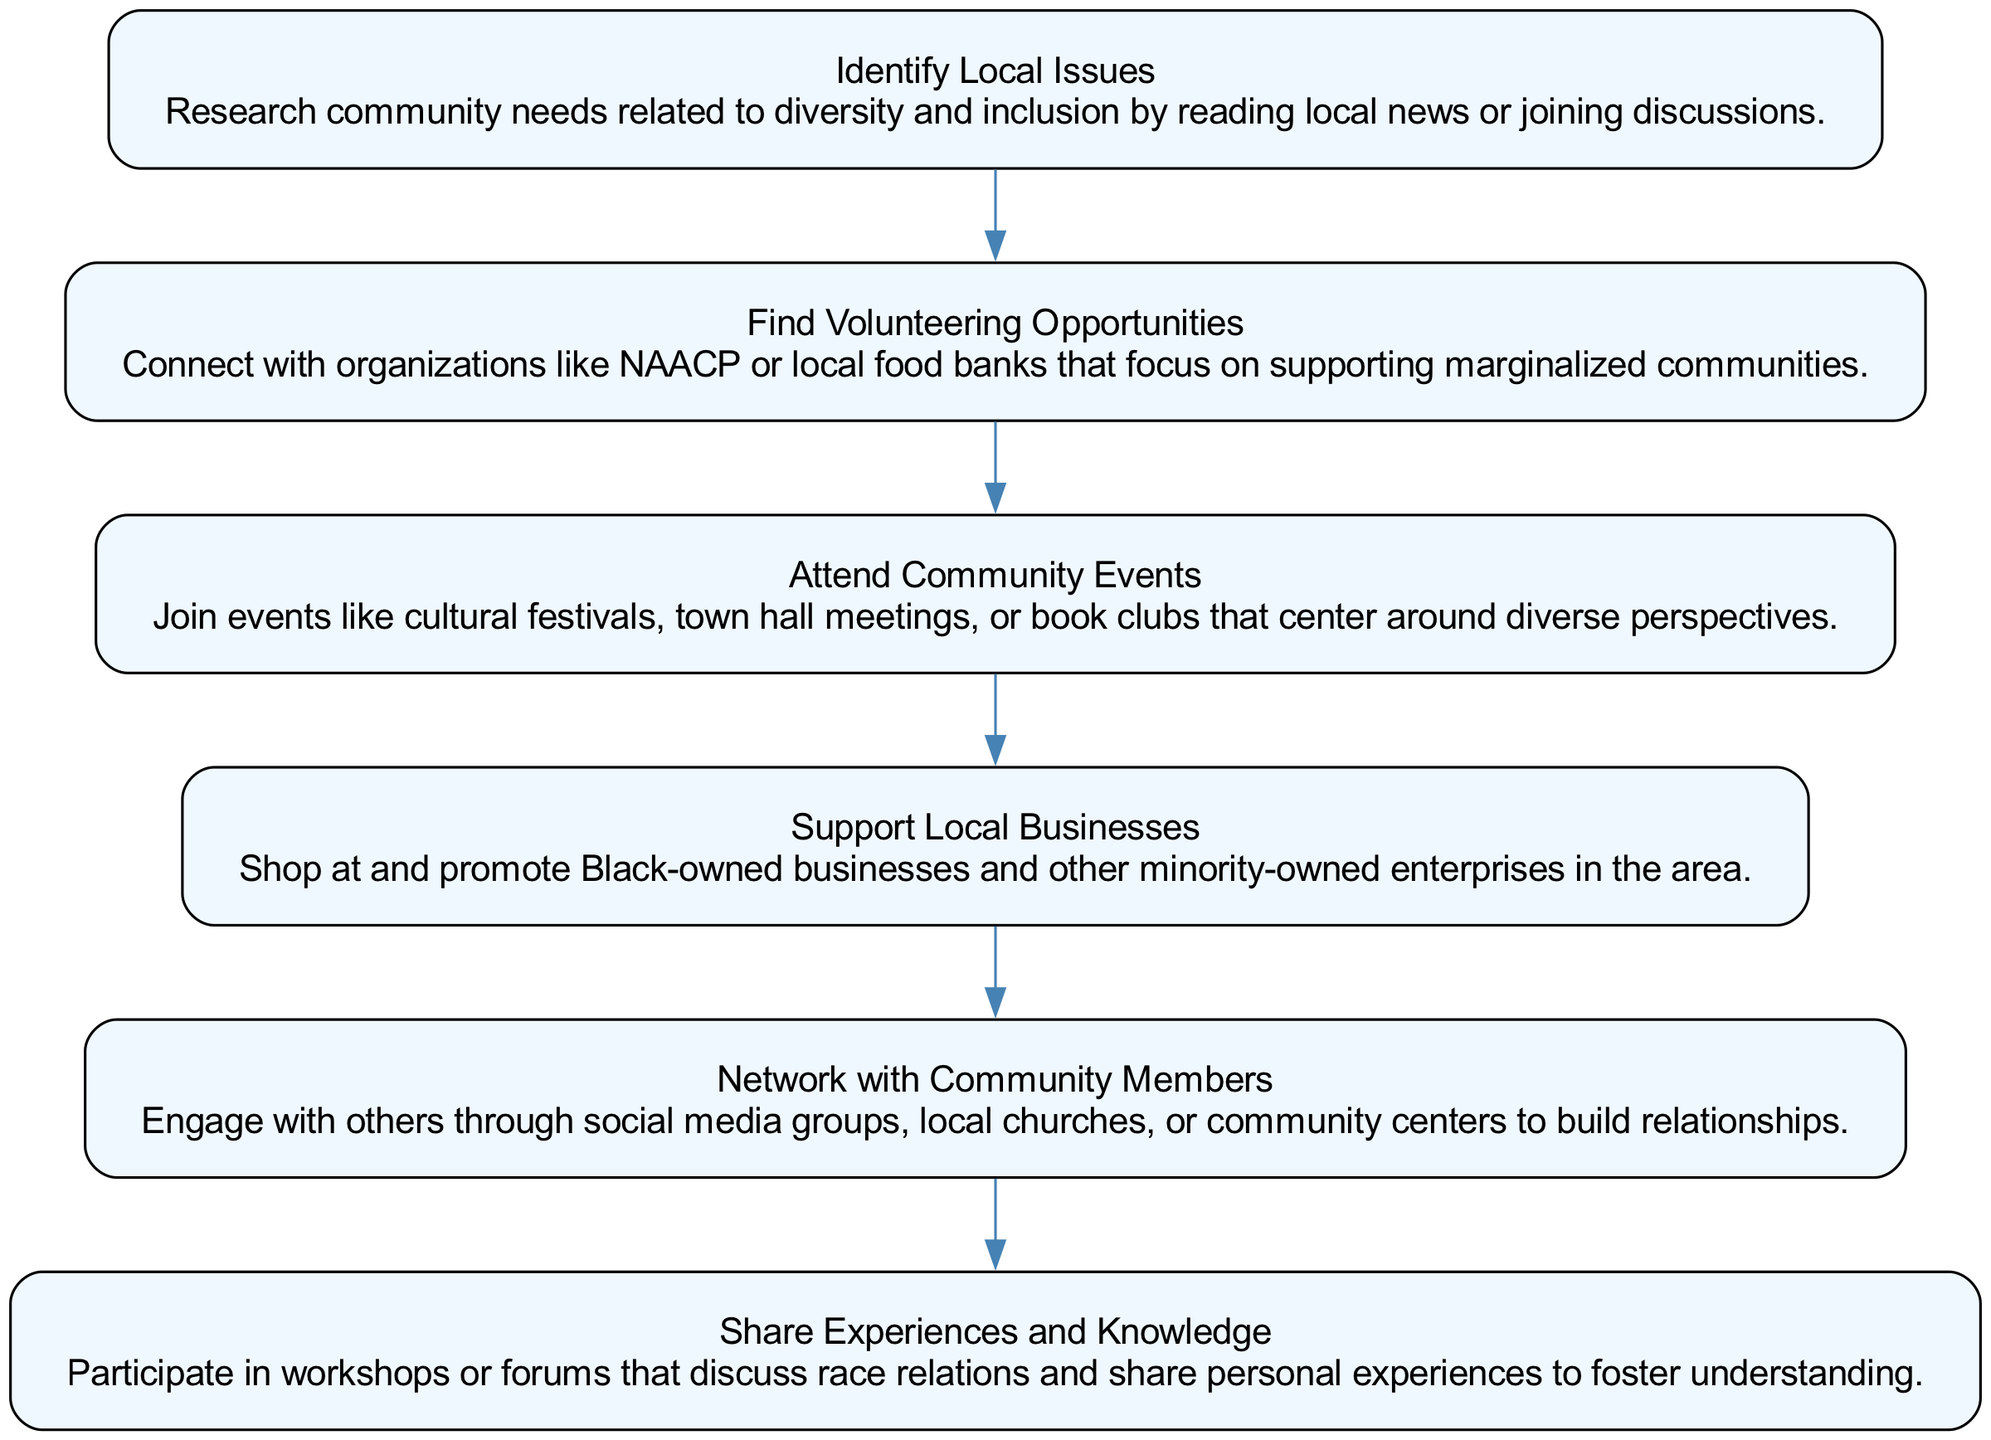What is the first step in the flow chart? The first step is "Identify Local Issues." It is labeled as the initial node and has no incoming edges.
Answer: Identify Local Issues How many steps are there in total? The flow chart contains six steps. Counting the nodes listed results in a total of six distinct actions.
Answer: 6 What does the third step involve? The third step is "Attend Community Events," which suggests joining events to engage with diverse perspectives.
Answer: Attend Community Events Which step directly follows "Find Volunteering Opportunities"? After "Find Volunteering Opportunities," the next step is "Attend Community Events," indicated by a direct edge connecting them.
Answer: Attend Community Events What is the purpose of the step "Share Experiences and Knowledge"? This step encourages participation in workshops or forums to discuss race relations and share personal experiences for better understanding.
Answer: Share Experiences and Knowledge How many steps focus on engagement with the community? Four steps focus on actively engaging with the community: "Find Volunteering Opportunities," "Attend Community Events," "Support Local Businesses," and "Network with Community Members." This indicates a focus on involvement.
Answer: 4 What is the last step in the flow chart? The last step is "Share Experiences and Knowledge," which signifies the conclusion of the engagement process in the chart.
Answer: Share Experiences and Knowledge Which two steps focus on supporting local businesses? The step "Support Local Businesses" is specifically dedicated to that, while "Find Volunteering Opportunities" indirectly supports by connecting to organizations that may include local businesses.
Answer: Support Local Businesses What type of activities are emphasized in the steps? The steps emphasize activities that promote diversity and inclusion, as indicated by the overall content of the actions described in each step.
Answer: Diversity and inclusion activities 